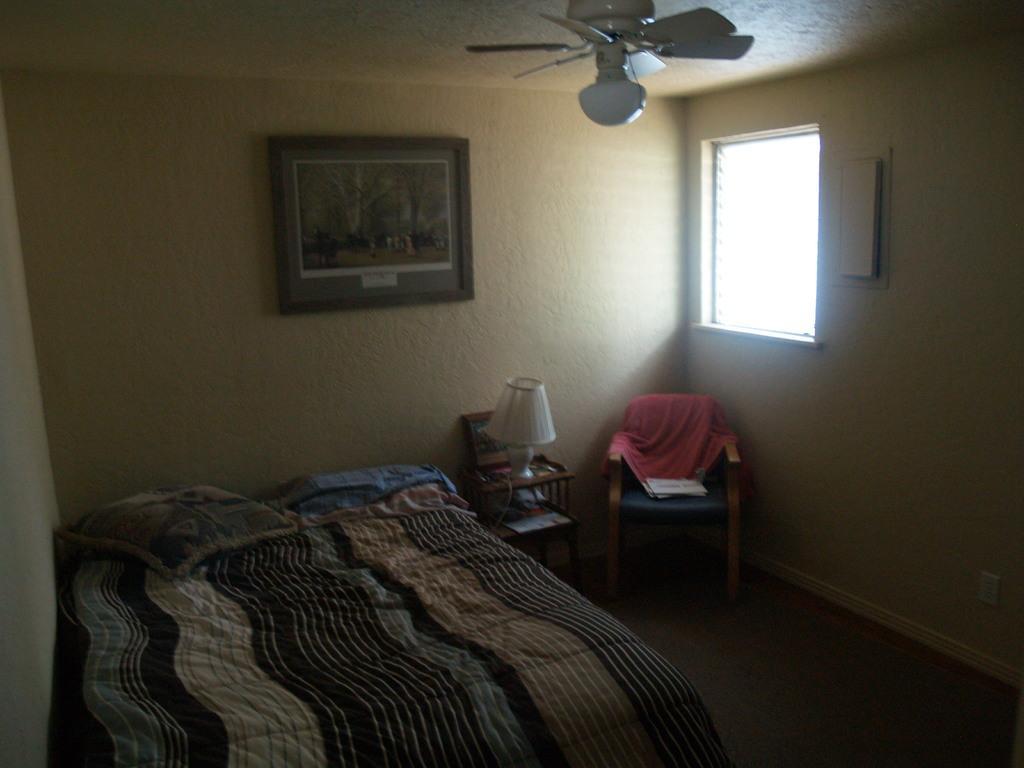How would you summarize this image in a sentence or two? This is a picture of the inside of a house in this picture, on the left side there is one bed. On the bed there are some pillows and blankets beside the bed there are two chairs, on the chairs there is one lamp and some towels and on the right side there is a window and on the wall there is one photo frame. On the top there is ceiling and one fan, at the bottom there is a floor. 